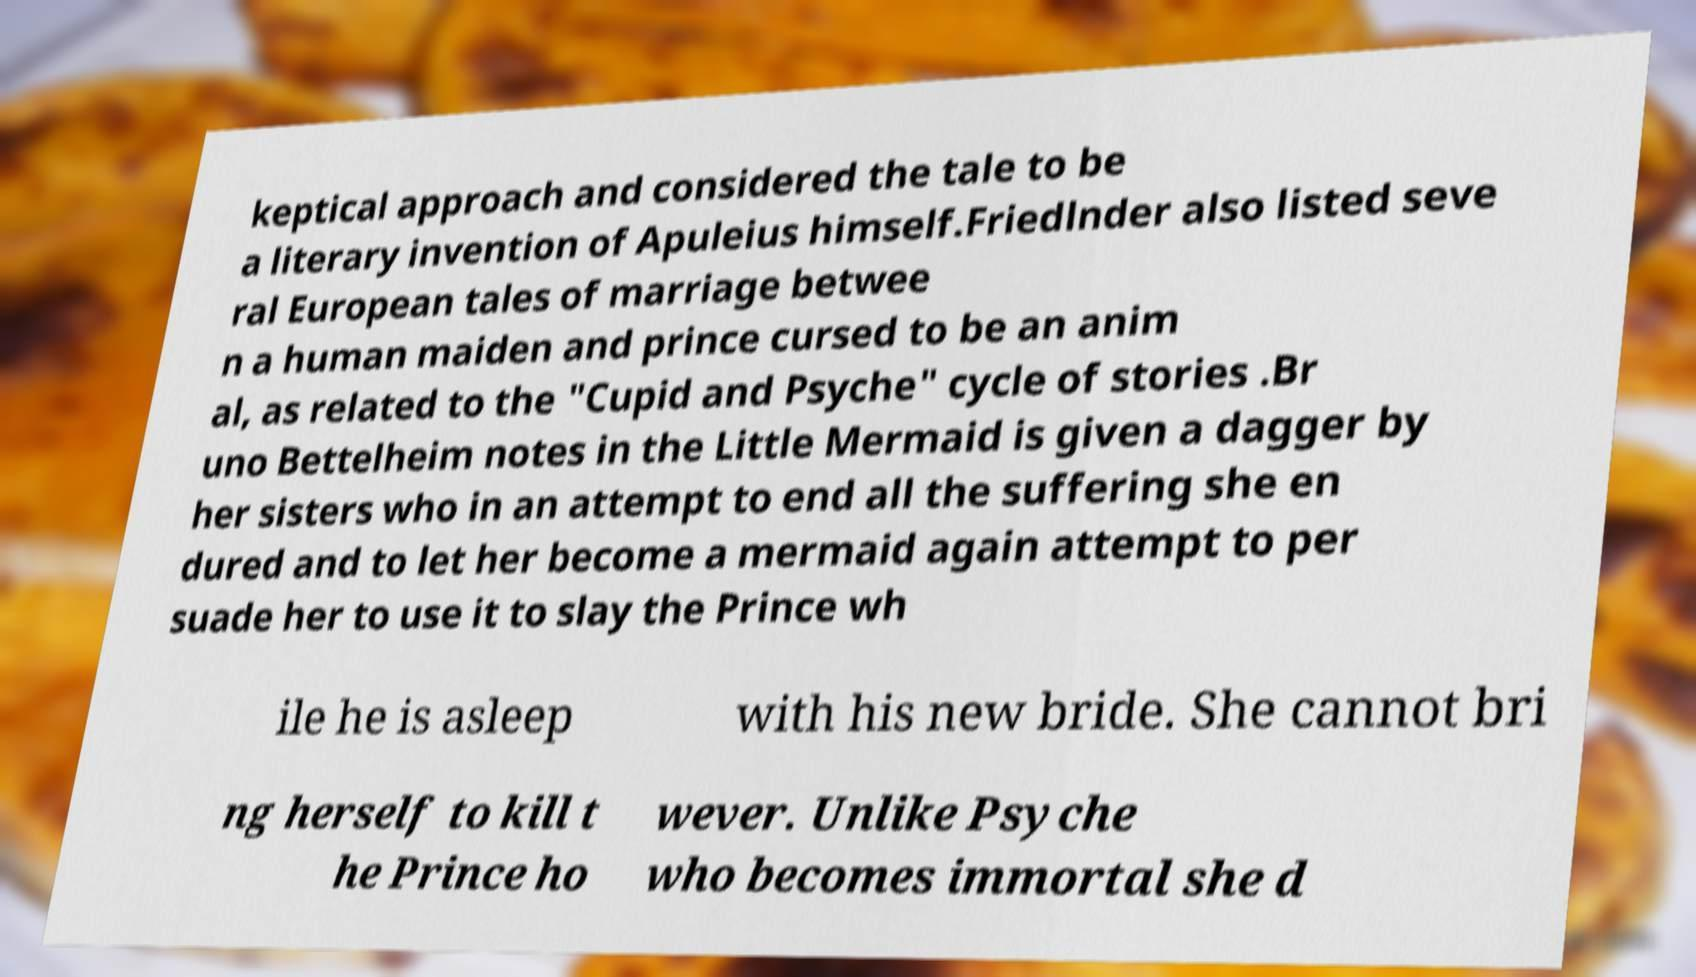For documentation purposes, I need the text within this image transcribed. Could you provide that? keptical approach and considered the tale to be a literary invention of Apuleius himself.Friedlnder also listed seve ral European tales of marriage betwee n a human maiden and prince cursed to be an anim al, as related to the "Cupid and Psyche" cycle of stories .Br uno Bettelheim notes in the Little Mermaid is given a dagger by her sisters who in an attempt to end all the suffering she en dured and to let her become a mermaid again attempt to per suade her to use it to slay the Prince wh ile he is asleep with his new bride. She cannot bri ng herself to kill t he Prince ho wever. Unlike Psyche who becomes immortal she d 